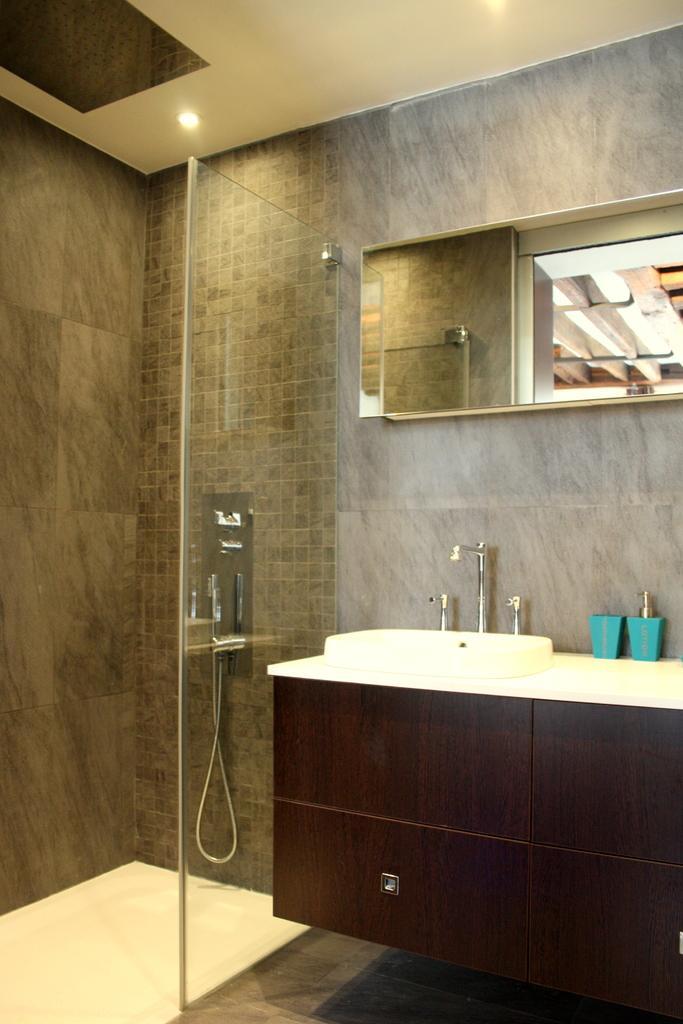Please provide a concise description of this image. This image is taken in the bathroom. In this image we can see the sink, mirror, sanitizer on the counter. We can also see the glass fence, hand shower and also the tiles wall. At the top there is ceiling with the lights and at the bottom we can see the surface. 